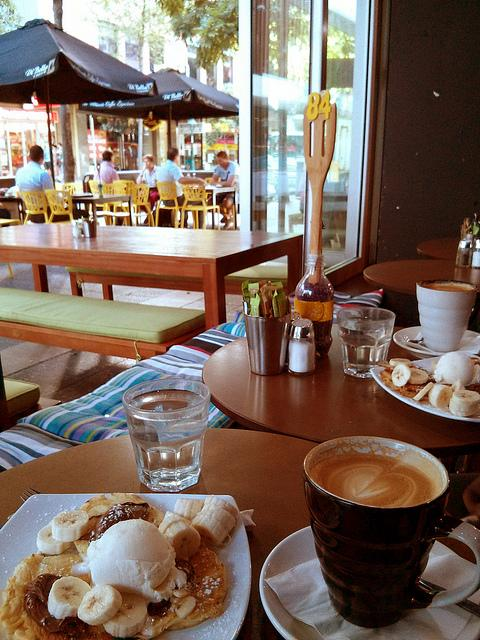What does the number 84 represent? Please explain your reasoning. order number. It helps the server get the right food to the right diners. 